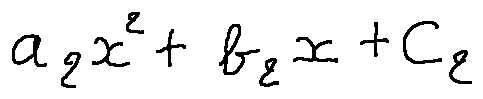Convert formula to latex. <formula><loc_0><loc_0><loc_500><loc_500>a _ { 2 } x ^ { 2 } + b _ { 2 } x + c _ { 2 }</formula> 